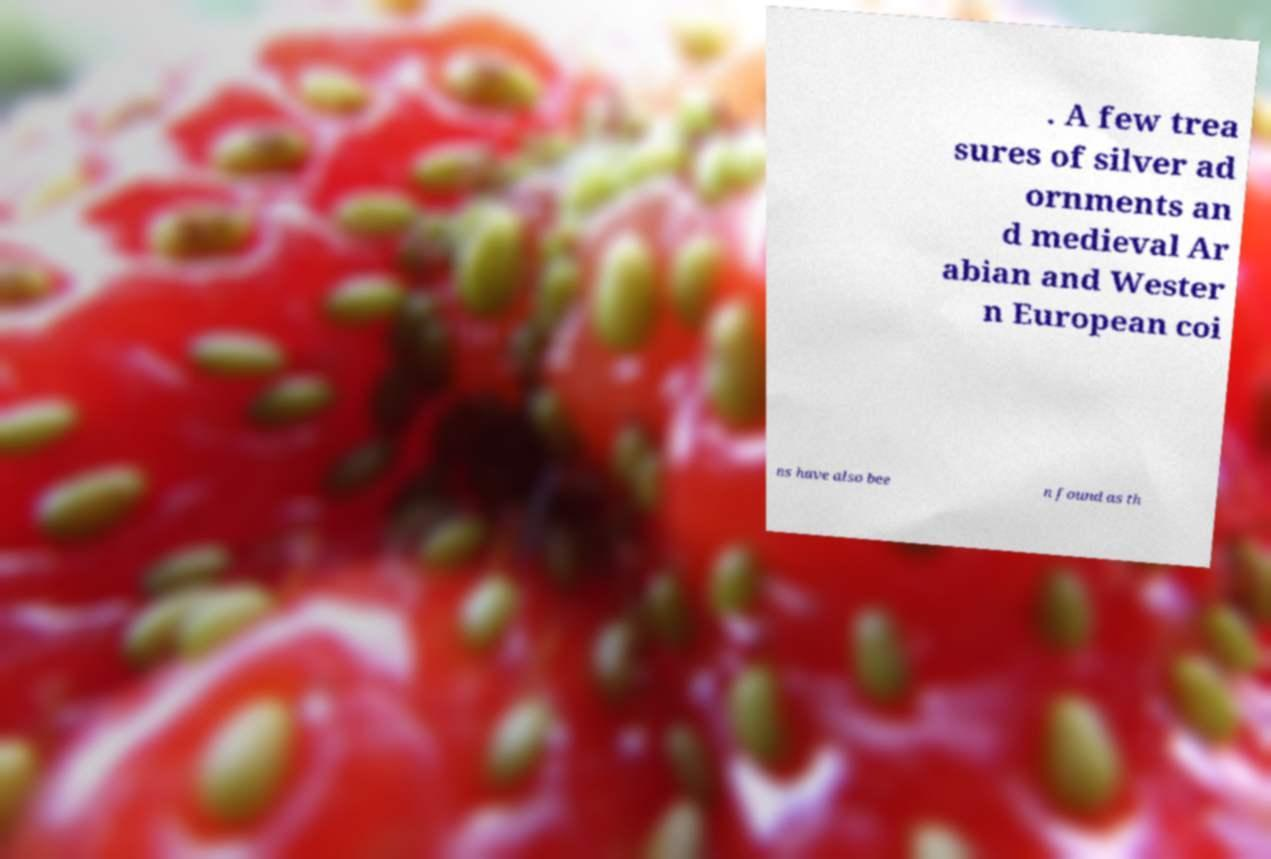Can you read and provide the text displayed in the image?This photo seems to have some interesting text. Can you extract and type it out for me? . A few trea sures of silver ad ornments an d medieval Ar abian and Wester n European coi ns have also bee n found as th 